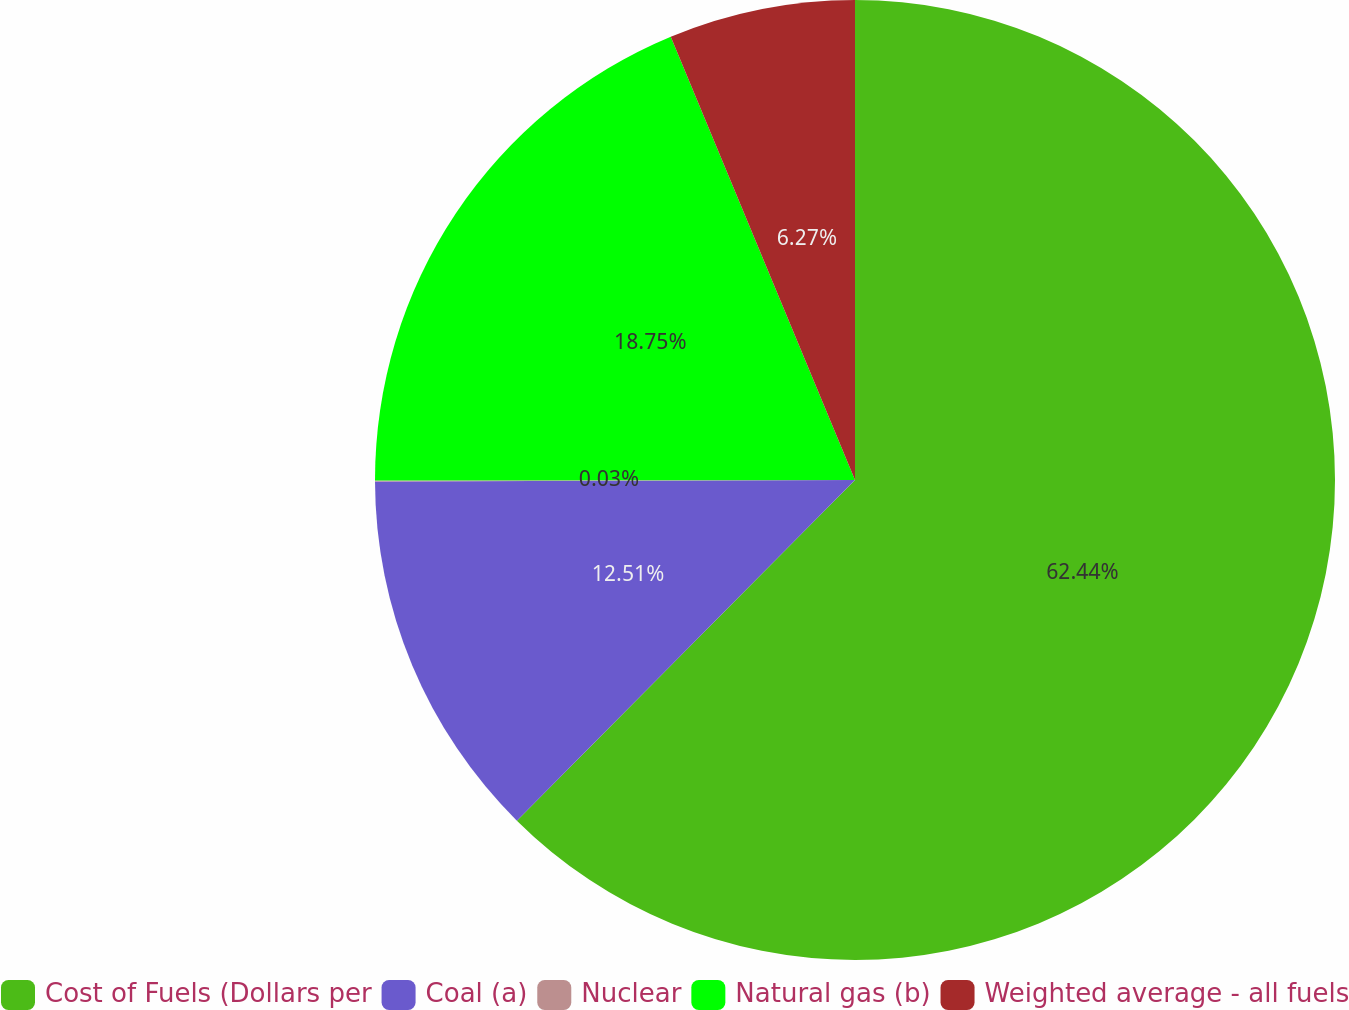<chart> <loc_0><loc_0><loc_500><loc_500><pie_chart><fcel>Cost of Fuels (Dollars per<fcel>Coal (a)<fcel>Nuclear<fcel>Natural gas (b)<fcel>Weighted average - all fuels<nl><fcel>62.44%<fcel>12.51%<fcel>0.03%<fcel>18.75%<fcel>6.27%<nl></chart> 